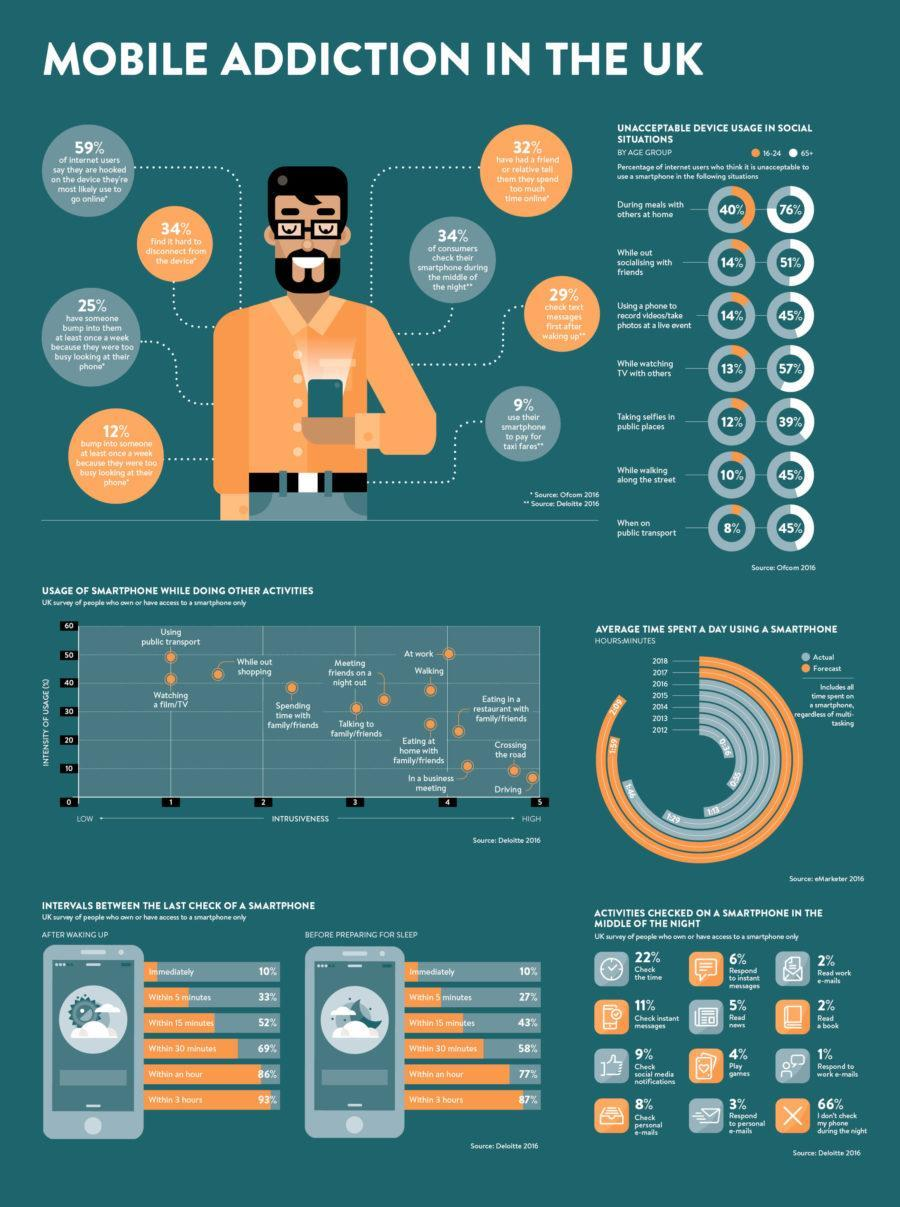What percentage of people do not check their mobile one hour before going to bed?
Answer the question with a short phrase. 33% What percentage of people do not check their smart phone within 30 minutes after waking up ? 31% What percentage of users do not use their phone at night? 66% What percentage of young adults think they should not use internet while socializing and at live events? 14% Which activities have the lowest intrusiveness of smart phone usage? Using pubic transport, Watching a film/ TV What percentage of senior citizens feel they should not use internet while at a live event, walking, or on a public transport? 45% How many young adults feel it is ok to take selfies in public places? 88% What is the percentage of people are likely to read a book at night? 2% What percentage difference in the young adults and senior citizens who feel using internet while watching TV in unacceptable? 44% What is the total percentage of people check smartphones immediately before sleeping or after waking up? 20% 